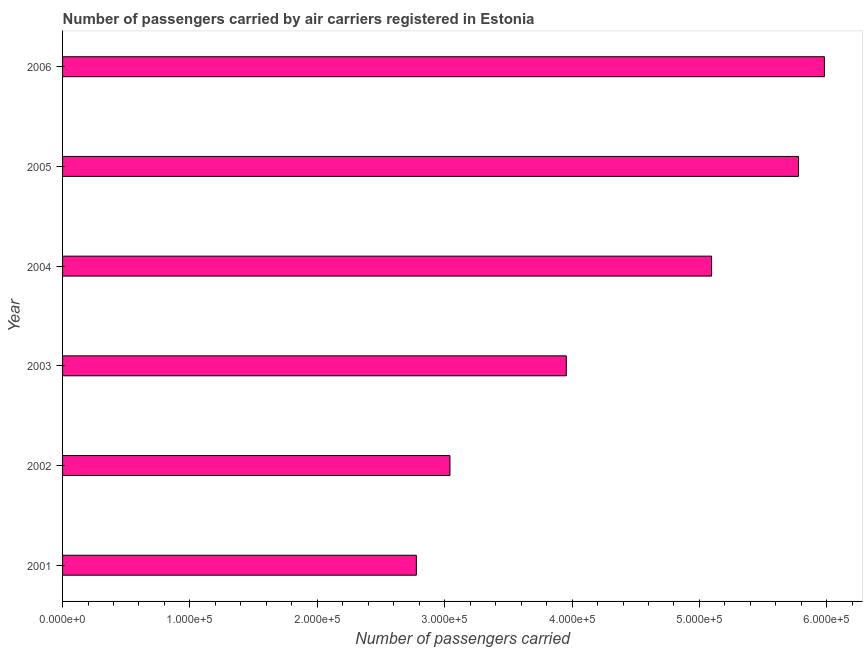Does the graph contain any zero values?
Your response must be concise. No. What is the title of the graph?
Your answer should be very brief. Number of passengers carried by air carriers registered in Estonia. What is the label or title of the X-axis?
Keep it short and to the point. Number of passengers carried. What is the number of passengers carried in 2005?
Provide a short and direct response. 5.78e+05. Across all years, what is the maximum number of passengers carried?
Give a very brief answer. 5.98e+05. Across all years, what is the minimum number of passengers carried?
Offer a terse response. 2.78e+05. In which year was the number of passengers carried minimum?
Provide a succinct answer. 2001. What is the sum of the number of passengers carried?
Your answer should be very brief. 2.66e+06. What is the difference between the number of passengers carried in 2001 and 2002?
Offer a very short reply. -2.64e+04. What is the average number of passengers carried per year?
Give a very brief answer. 4.44e+05. What is the median number of passengers carried?
Offer a terse response. 4.53e+05. In how many years, is the number of passengers carried greater than 340000 ?
Keep it short and to the point. 4. Do a majority of the years between 2002 and 2005 (inclusive) have number of passengers carried greater than 440000 ?
Provide a short and direct response. No. What is the ratio of the number of passengers carried in 2002 to that in 2003?
Keep it short and to the point. 0.77. Is the number of passengers carried in 2001 less than that in 2006?
Your answer should be very brief. Yes. What is the difference between the highest and the second highest number of passengers carried?
Provide a short and direct response. 2.03e+04. What is the difference between the highest and the lowest number of passengers carried?
Offer a terse response. 3.20e+05. How many bars are there?
Offer a terse response. 6. How many years are there in the graph?
Offer a very short reply. 6. What is the Number of passengers carried in 2001?
Make the answer very short. 2.78e+05. What is the Number of passengers carried of 2002?
Keep it short and to the point. 3.04e+05. What is the Number of passengers carried of 2003?
Provide a short and direct response. 3.95e+05. What is the Number of passengers carried in 2004?
Provide a succinct answer. 5.10e+05. What is the Number of passengers carried of 2005?
Your answer should be compact. 5.78e+05. What is the Number of passengers carried of 2006?
Provide a short and direct response. 5.98e+05. What is the difference between the Number of passengers carried in 2001 and 2002?
Keep it short and to the point. -2.64e+04. What is the difference between the Number of passengers carried in 2001 and 2003?
Your answer should be very brief. -1.18e+05. What is the difference between the Number of passengers carried in 2001 and 2004?
Provide a short and direct response. -2.32e+05. What is the difference between the Number of passengers carried in 2001 and 2005?
Offer a very short reply. -3.00e+05. What is the difference between the Number of passengers carried in 2001 and 2006?
Your response must be concise. -3.20e+05. What is the difference between the Number of passengers carried in 2002 and 2003?
Your answer should be very brief. -9.14e+04. What is the difference between the Number of passengers carried in 2002 and 2004?
Your response must be concise. -2.05e+05. What is the difference between the Number of passengers carried in 2002 and 2005?
Make the answer very short. -2.74e+05. What is the difference between the Number of passengers carried in 2002 and 2006?
Provide a short and direct response. -2.94e+05. What is the difference between the Number of passengers carried in 2003 and 2004?
Make the answer very short. -1.14e+05. What is the difference between the Number of passengers carried in 2003 and 2005?
Give a very brief answer. -1.82e+05. What is the difference between the Number of passengers carried in 2003 and 2006?
Offer a very short reply. -2.03e+05. What is the difference between the Number of passengers carried in 2004 and 2005?
Your answer should be very brief. -6.83e+04. What is the difference between the Number of passengers carried in 2004 and 2006?
Your answer should be very brief. -8.86e+04. What is the difference between the Number of passengers carried in 2005 and 2006?
Your response must be concise. -2.03e+04. What is the ratio of the Number of passengers carried in 2001 to that in 2003?
Offer a terse response. 0.7. What is the ratio of the Number of passengers carried in 2001 to that in 2004?
Offer a terse response. 0.55. What is the ratio of the Number of passengers carried in 2001 to that in 2005?
Provide a short and direct response. 0.48. What is the ratio of the Number of passengers carried in 2001 to that in 2006?
Offer a terse response. 0.46. What is the ratio of the Number of passengers carried in 2002 to that in 2003?
Give a very brief answer. 0.77. What is the ratio of the Number of passengers carried in 2002 to that in 2004?
Offer a very short reply. 0.6. What is the ratio of the Number of passengers carried in 2002 to that in 2005?
Keep it short and to the point. 0.53. What is the ratio of the Number of passengers carried in 2002 to that in 2006?
Keep it short and to the point. 0.51. What is the ratio of the Number of passengers carried in 2003 to that in 2004?
Ensure brevity in your answer.  0.78. What is the ratio of the Number of passengers carried in 2003 to that in 2005?
Give a very brief answer. 0.68. What is the ratio of the Number of passengers carried in 2003 to that in 2006?
Offer a terse response. 0.66. What is the ratio of the Number of passengers carried in 2004 to that in 2005?
Make the answer very short. 0.88. What is the ratio of the Number of passengers carried in 2004 to that in 2006?
Make the answer very short. 0.85. 